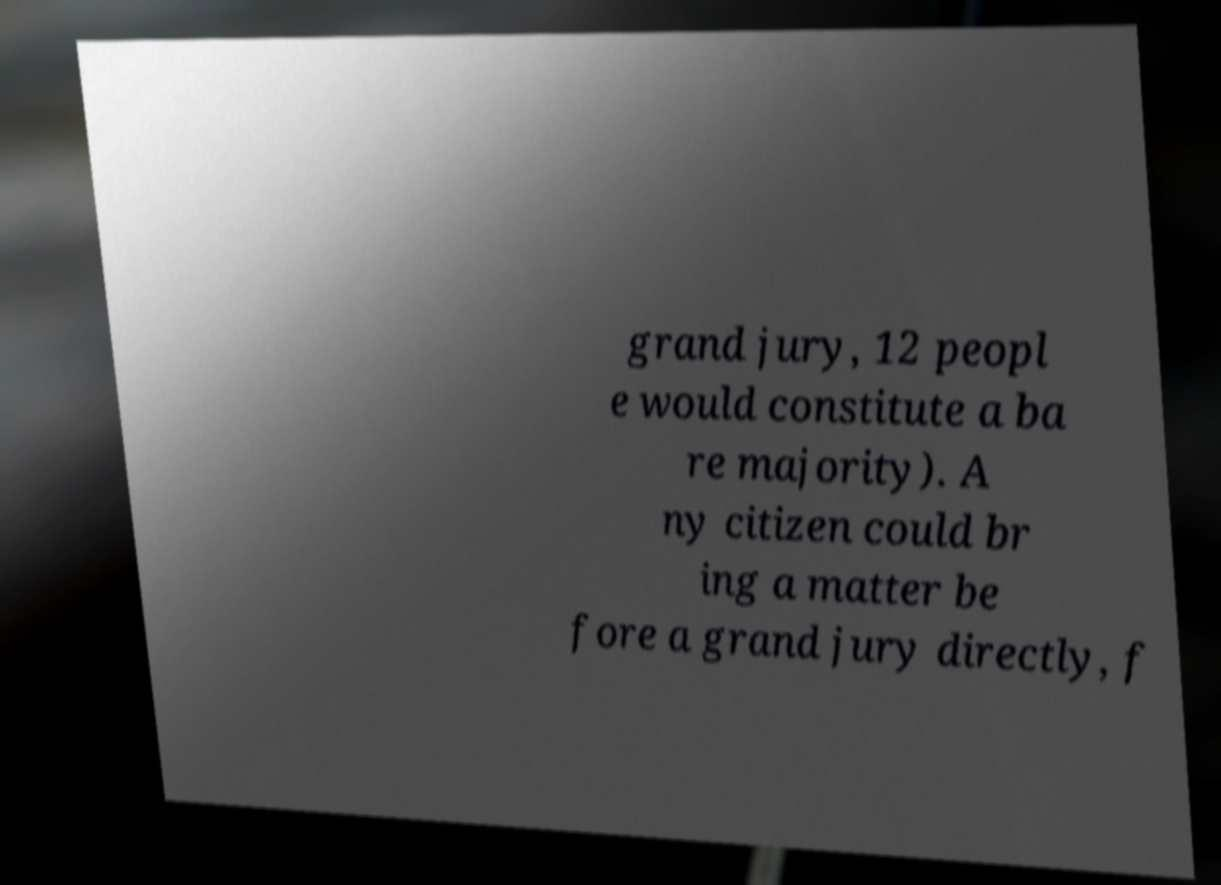Can you read and provide the text displayed in the image?This photo seems to have some interesting text. Can you extract and type it out for me? grand jury, 12 peopl e would constitute a ba re majority). A ny citizen could br ing a matter be fore a grand jury directly, f 